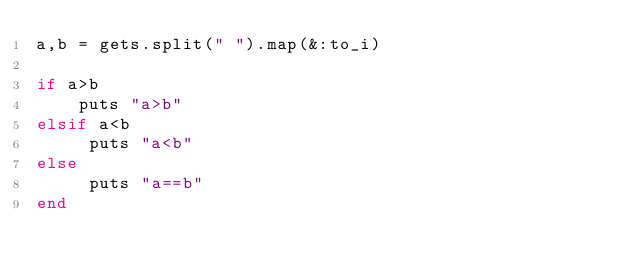<code> <loc_0><loc_0><loc_500><loc_500><_Ruby_>a,b = gets.split(" ").map(&:to_i)

if a>b
    puts "a>b"
elsif a<b
     puts "a<b"
else
     puts "a==b"
end</code> 